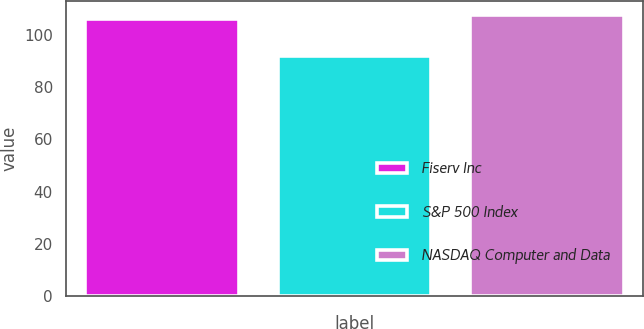Convert chart. <chart><loc_0><loc_0><loc_500><loc_500><bar_chart><fcel>Fiserv Inc<fcel>S&P 500 Index<fcel>NASDAQ Computer and Data<nl><fcel>106<fcel>92<fcel>107.5<nl></chart> 